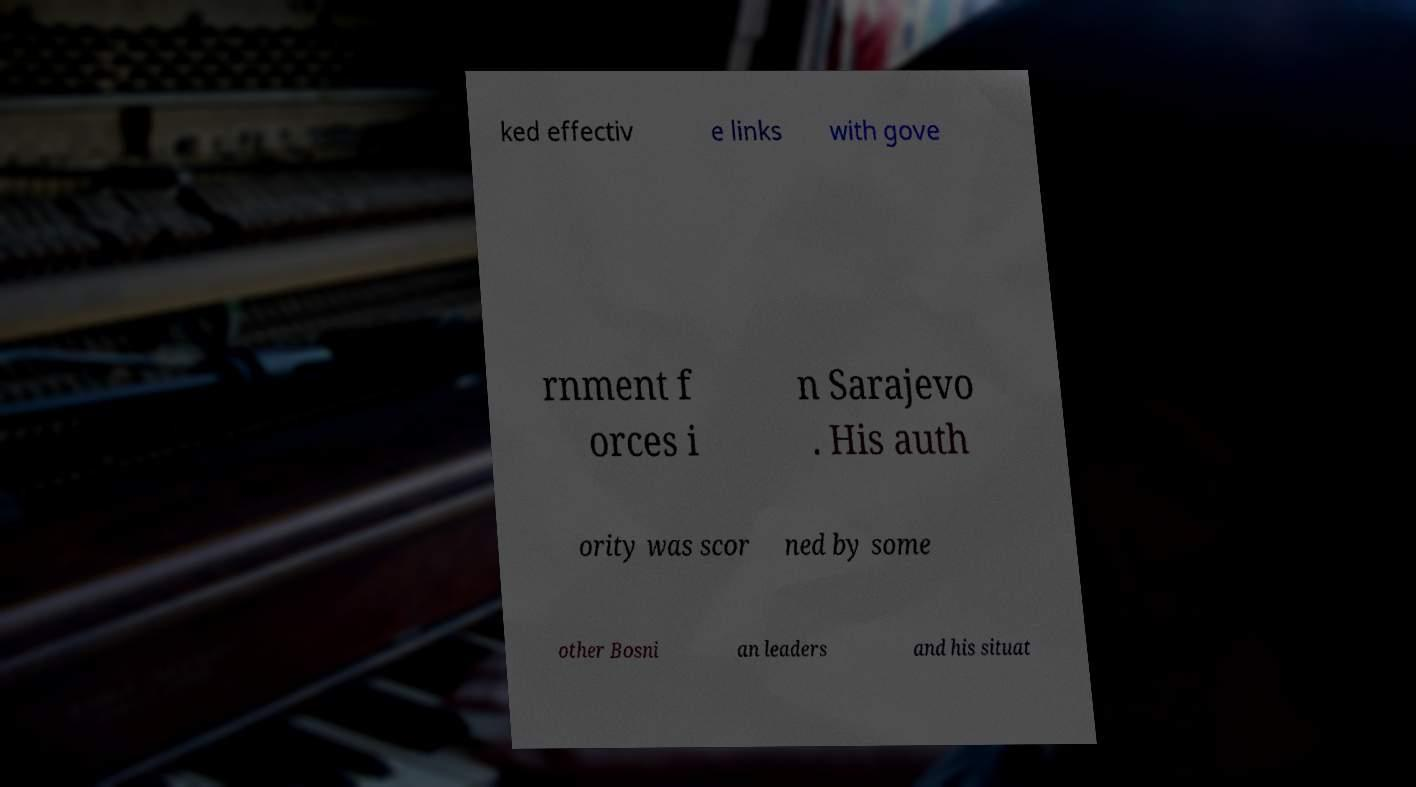Could you assist in decoding the text presented in this image and type it out clearly? ked effectiv e links with gove rnment f orces i n Sarajevo . His auth ority was scor ned by some other Bosni an leaders and his situat 